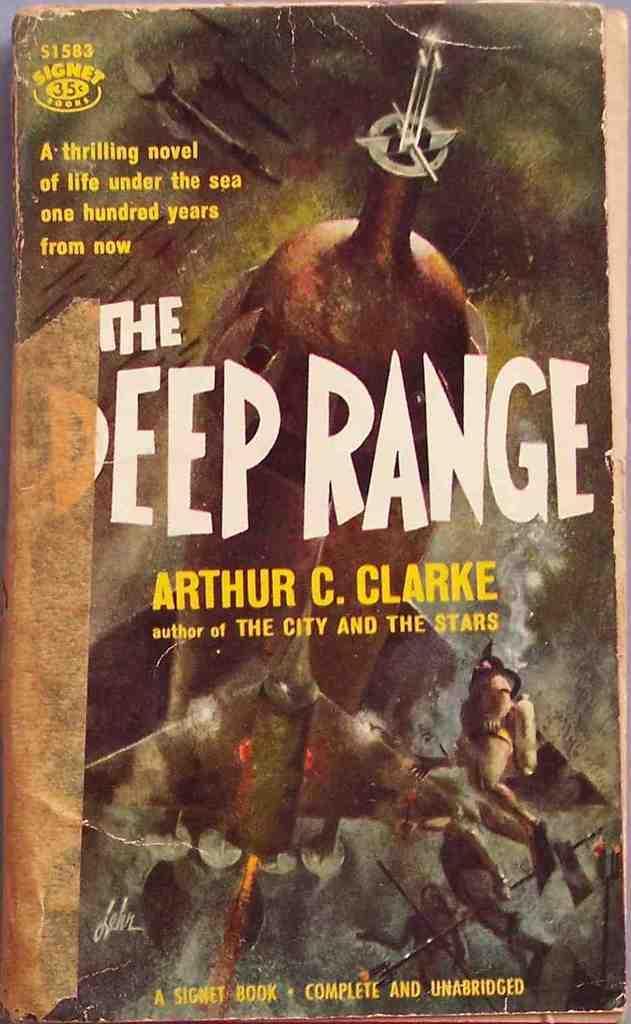Can you describe this image briefly? In the center of the image we can see a poster. On the poster, we can see some text and a few other objects. 